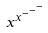Convert formula to latex. <formula><loc_0><loc_0><loc_500><loc_500>x ^ { x ^ { - ^ { - ^ { - } } } }</formula> 